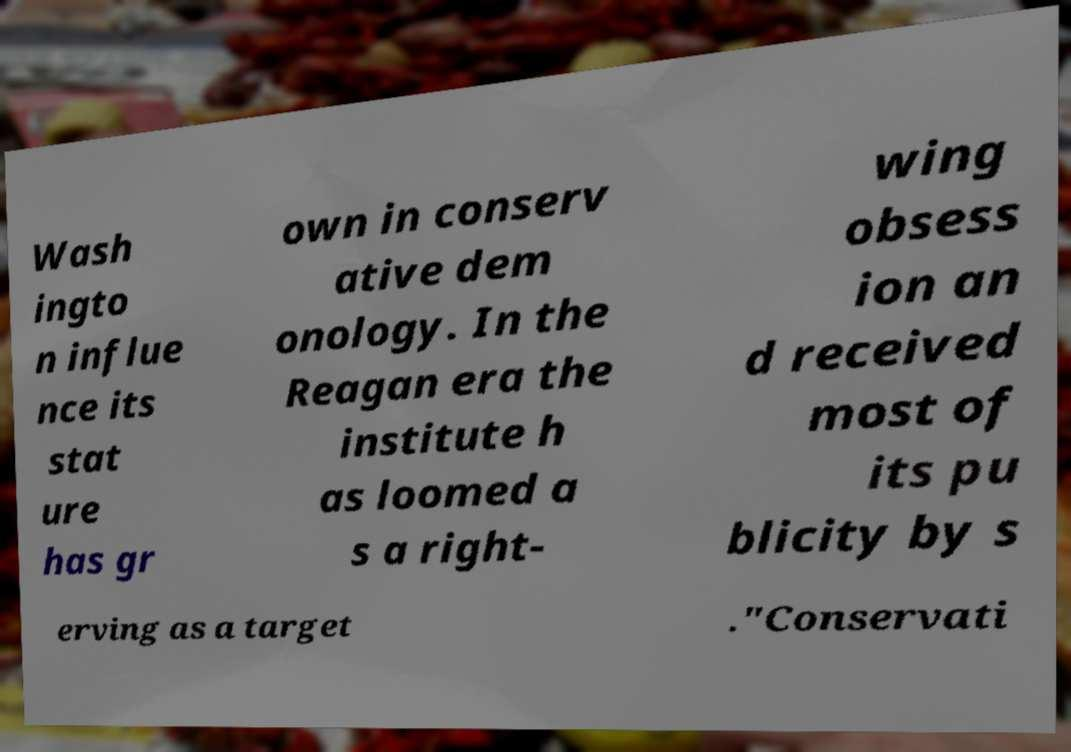Please identify and transcribe the text found in this image. Wash ingto n influe nce its stat ure has gr own in conserv ative dem onology. In the Reagan era the institute h as loomed a s a right- wing obsess ion an d received most of its pu blicity by s erving as a target ."Conservati 